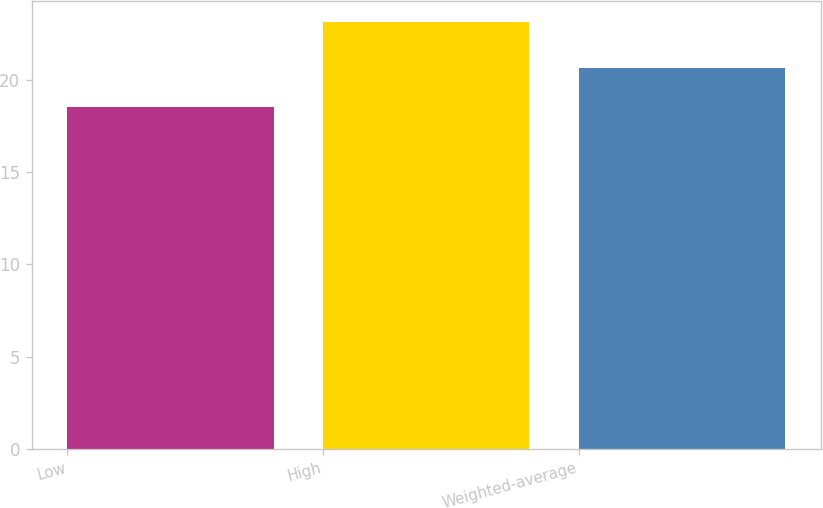Convert chart to OTSL. <chart><loc_0><loc_0><loc_500><loc_500><bar_chart><fcel>Low<fcel>High<fcel>Weighted-average<nl><fcel>18.5<fcel>23.1<fcel>20.6<nl></chart> 